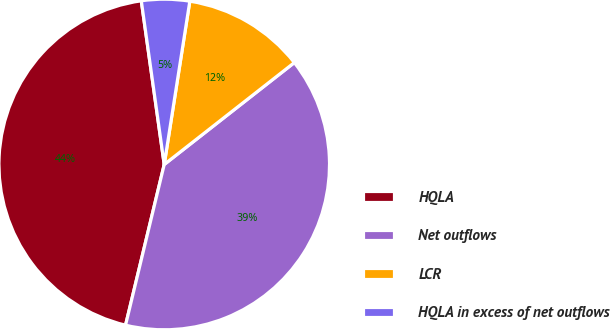Convert chart. <chart><loc_0><loc_0><loc_500><loc_500><pie_chart><fcel>HQLA<fcel>Net outflows<fcel>LCR<fcel>HQLA in excess of net outflows<nl><fcel>44.02%<fcel>39.33%<fcel>11.95%<fcel>4.69%<nl></chart> 